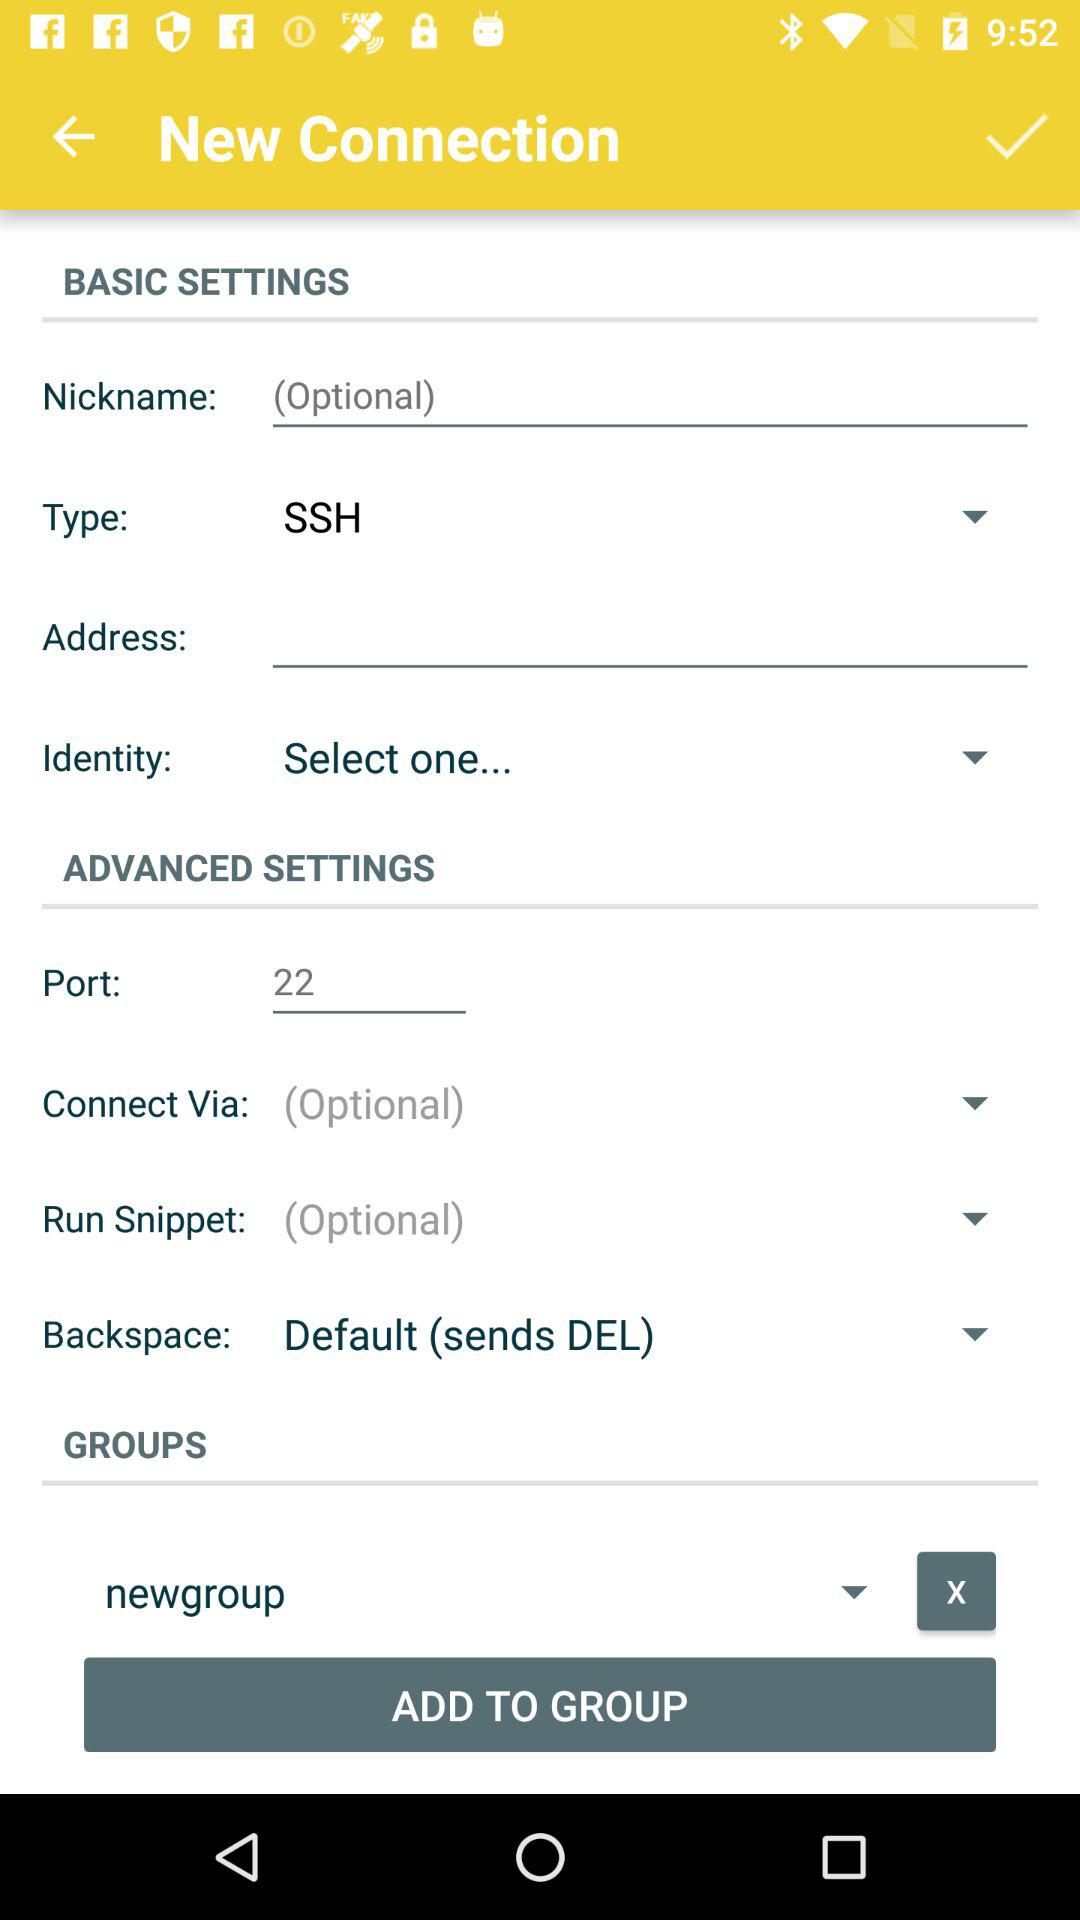What is selected for "Backspace"? The selected option is "Default (sends DEL)". 